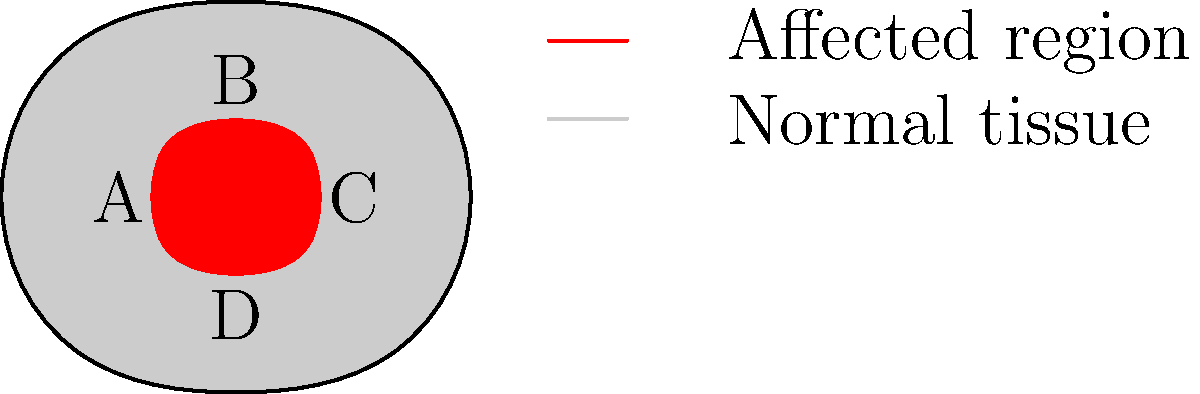Based on the color-coded brain scan provided, which regions are primarily affected by the neurological disorder under investigation? To identify the affected brain regions, we need to analyze the color-coded brain scan:

1. The brain scan shows a simplified cross-section of the brain with four labeled regions: A, B, C, and D.

2. The legend indicates that red areas represent affected regions, while gray areas represent normal tissue.

3. Examining the scan, we can observe:
   - Region A (lower left) appears gray, indicating normal tissue.
   - Region B (upper center) is colored red, suggesting it is affected by the disorder.
   - Region C (lower right) appears gray, indicating normal tissue.
   - Region D (lower center) is colored red, suggesting it is also affected by the disorder.

4. The affected regions are symmetrically located in the upper and lower central areas of the brain cross-section.

5. Based on this analysis, we can conclude that regions B and D are primarily affected by the neurological disorder under investigation.
Answer: Regions B and D 